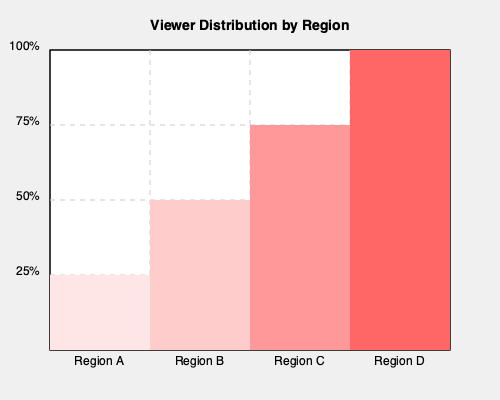As a documentary filmmaker analyzing viewer engagement, you've created a choropleth map showing the percentage of viewers in different regions. Based on the map, which region has the highest viewer engagement, and what percentage of total viewers does it represent? How would this information influence your audience targeting strategy? To answer this question, we need to analyze the choropleth map provided:

1. Identify the regions:
   The map shows four regions: A, B, C, and D.

2. Interpret the color gradient:
   Darker shades of red indicate higher viewer engagement percentages.

3. Analyze the percentages:
   - Region A: 25% (lowest)
   - Region B: 50%
   - Region C: 75%
   - Region D: 100% (highest)

4. Identify the region with highest engagement:
   Region D has the darkest shade, representing 100% viewer engagement.

5. Calculate the percentage of total viewers:
   To find the percentage of total viewers in Region D, we need to calculate its share of the total engagement across all regions.

   Total engagement: 25% + 50% + 75% + 100% = 250%
   Region D's share: 100% / 250% = 0.4 = 40%

6. Audience targeting strategy:
   This information suggests focusing marketing efforts and content distribution primarily on Region D, as it represents the largest and most engaged audience segment. However, Regions C and B also show significant engagement and shouldn't be neglected.

   A balanced strategy might involve:
   a) Prioritizing content delivery and promotional activities in Region D
   b) Developing targeted content that appeals to the preferences of viewers in Region D
   c) Allocating resources to maintain and grow engagement in Regions C and B
   d) Investigating reasons for low engagement in Region A and potentially developing strategies to increase viewership there
Answer: Region D; 40% of total viewers. Strategy: Prioritize Region D while maintaining focus on C and B; investigate low engagement in A. 